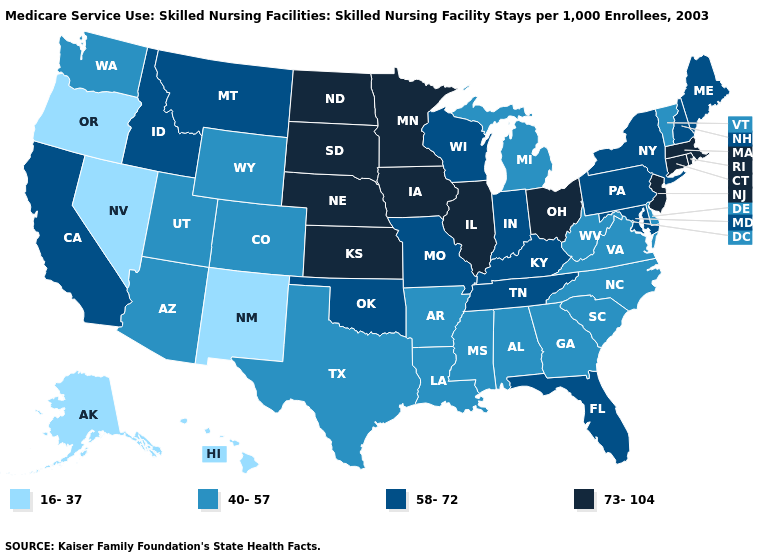What is the highest value in states that border Oregon?
Keep it brief. 58-72. Among the states that border Rhode Island , which have the highest value?
Quick response, please. Connecticut, Massachusetts. Does Missouri have the lowest value in the MidWest?
Answer briefly. No. What is the value of Texas?
Give a very brief answer. 40-57. Name the states that have a value in the range 40-57?
Write a very short answer. Alabama, Arizona, Arkansas, Colorado, Delaware, Georgia, Louisiana, Michigan, Mississippi, North Carolina, South Carolina, Texas, Utah, Vermont, Virginia, Washington, West Virginia, Wyoming. Does the first symbol in the legend represent the smallest category?
Concise answer only. Yes. Does the map have missing data?
Keep it brief. No. What is the value of Vermont?
Short answer required. 40-57. Does Vermont have a higher value than Alaska?
Write a very short answer. Yes. Name the states that have a value in the range 73-104?
Answer briefly. Connecticut, Illinois, Iowa, Kansas, Massachusetts, Minnesota, Nebraska, New Jersey, North Dakota, Ohio, Rhode Island, South Dakota. What is the value of Alaska?
Concise answer only. 16-37. What is the value of Virginia?
Answer briefly. 40-57. Does Nebraska have the same value as Oklahoma?
Concise answer only. No. Which states have the highest value in the USA?
Quick response, please. Connecticut, Illinois, Iowa, Kansas, Massachusetts, Minnesota, Nebraska, New Jersey, North Dakota, Ohio, Rhode Island, South Dakota. What is the value of Arkansas?
Short answer required. 40-57. 